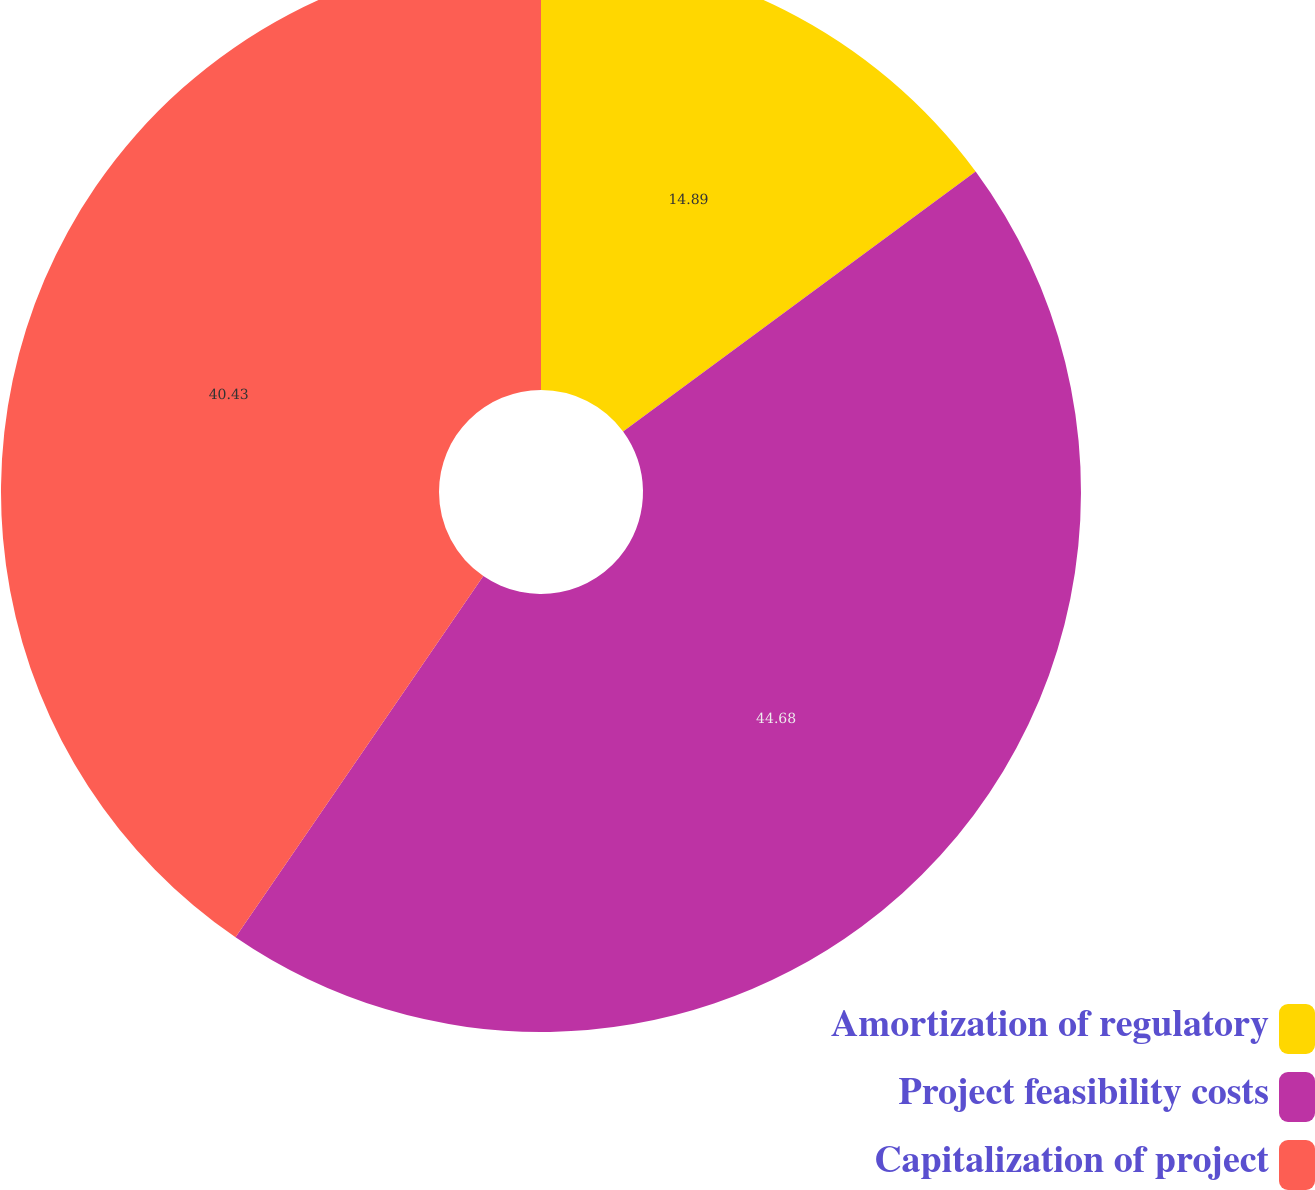<chart> <loc_0><loc_0><loc_500><loc_500><pie_chart><fcel>Amortization of regulatory<fcel>Project feasibility costs<fcel>Capitalization of project<nl><fcel>14.89%<fcel>44.68%<fcel>40.43%<nl></chart> 